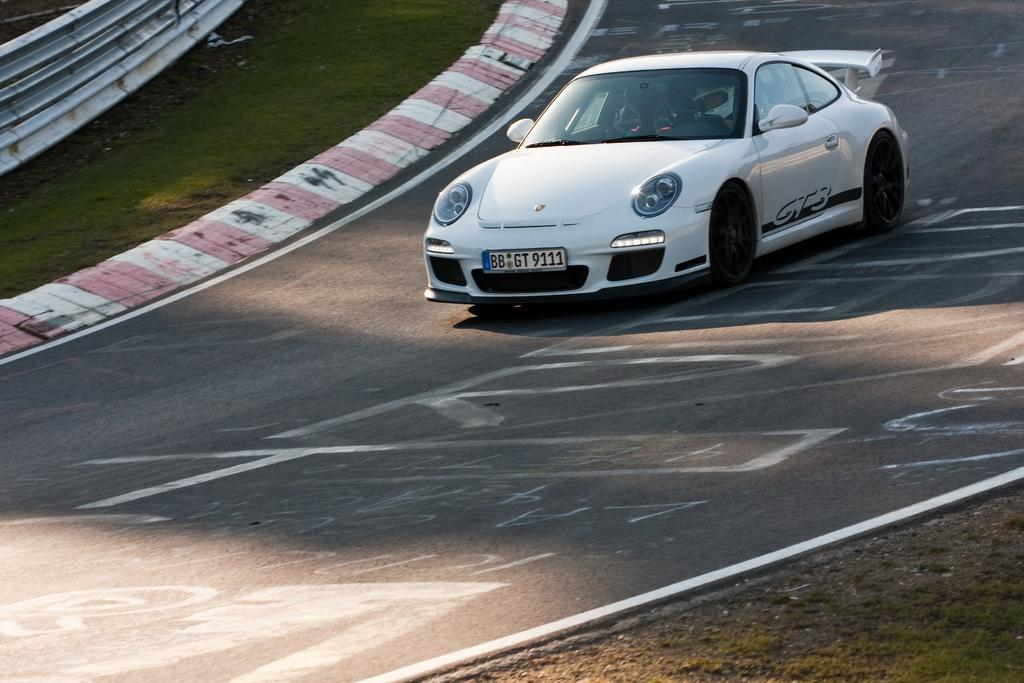What type of vehicle is in the image? There is a white color race car in the image. Where is the race car located? The race car is on a path. What can be seen in the background of the image? There is an iron sheet and grass in the background of the image. Where is the scarecrow located in the image? There is no scarecrow present in the image. What type of trail does the race car follow in the image? The provided facts do not mention a trail; the race car is simply on a path. 